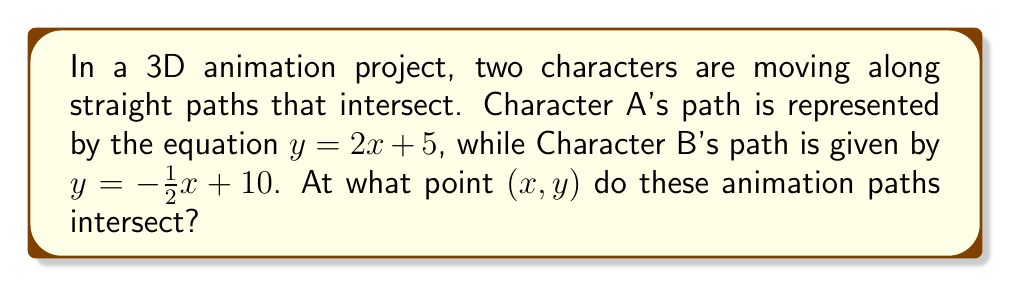Provide a solution to this math problem. To find the intersection point of these two lines, we need to solve the system of equations:

$$\begin{cases}
y = 2x + 5 \\
y = -\frac{1}{2}x + 10
\end{cases}$$

Step 1: Set the two equations equal to each other since they represent the same y-coordinate at the intersection point.
$2x + 5 = -\frac{1}{2}x + 10$

Step 2: Solve for x by adding $\frac{1}{2}x$ to both sides and subtracting 5 from both sides.
$\frac{5}{2}x = 5$

Step 3: Divide both sides by $\frac{5}{2}$ to isolate x.
$x = 2$

Step 4: Substitute this x-value into either of the original equations to find y. Let's use the first equation:
$y = 2(2) + 5 = 4 + 5 = 9$

Therefore, the intersection point is $(2, 9)$.

[asy]
unitsize(1cm);
draw((-1,3)--(5,15),blue);
draw((-1,10.5)--(5,7.5),red);
dot((2,9));
label("(2, 9)", (2,9), NE);
label("y = 2x + 5", (4,13), E, blue);
label("y = -1/2x + 10", (4,8), E, red);
[/asy]
Answer: $(2, 9)$ 